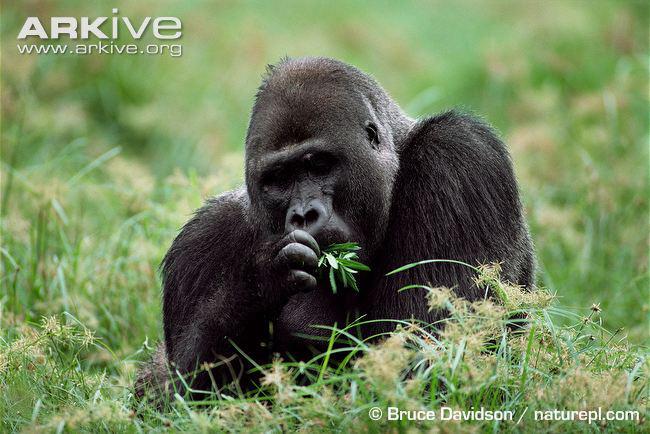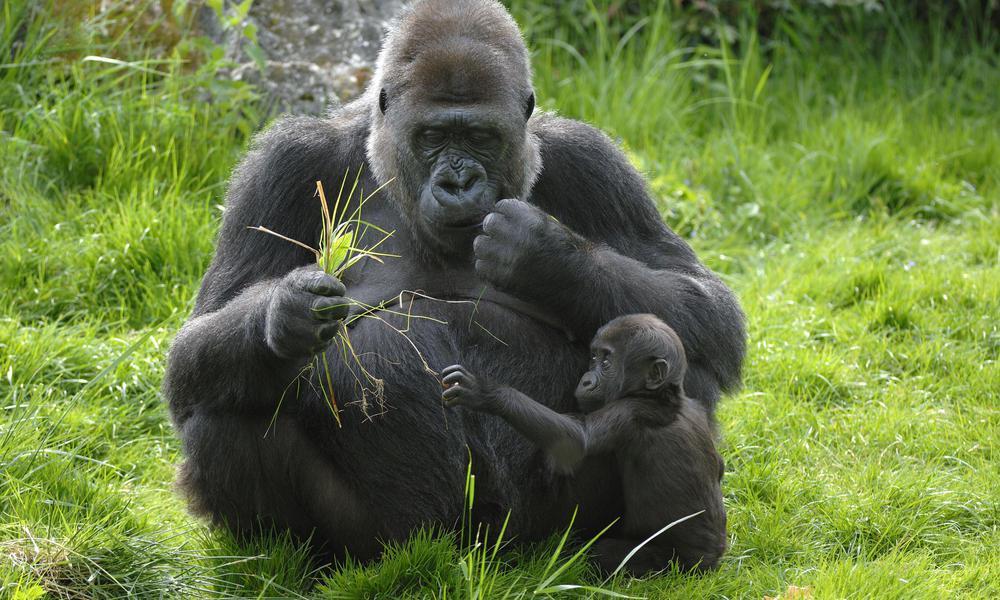The first image is the image on the left, the second image is the image on the right. For the images shown, is this caption "The left image shows a lone gorilla munching foliage, and the right image shows at least one adult gorilla with a baby gorilla." true? Answer yes or no. Yes. The first image is the image on the left, the second image is the image on the right. Given the left and right images, does the statement "There are at least two gorillas in the right image." hold true? Answer yes or no. Yes. 